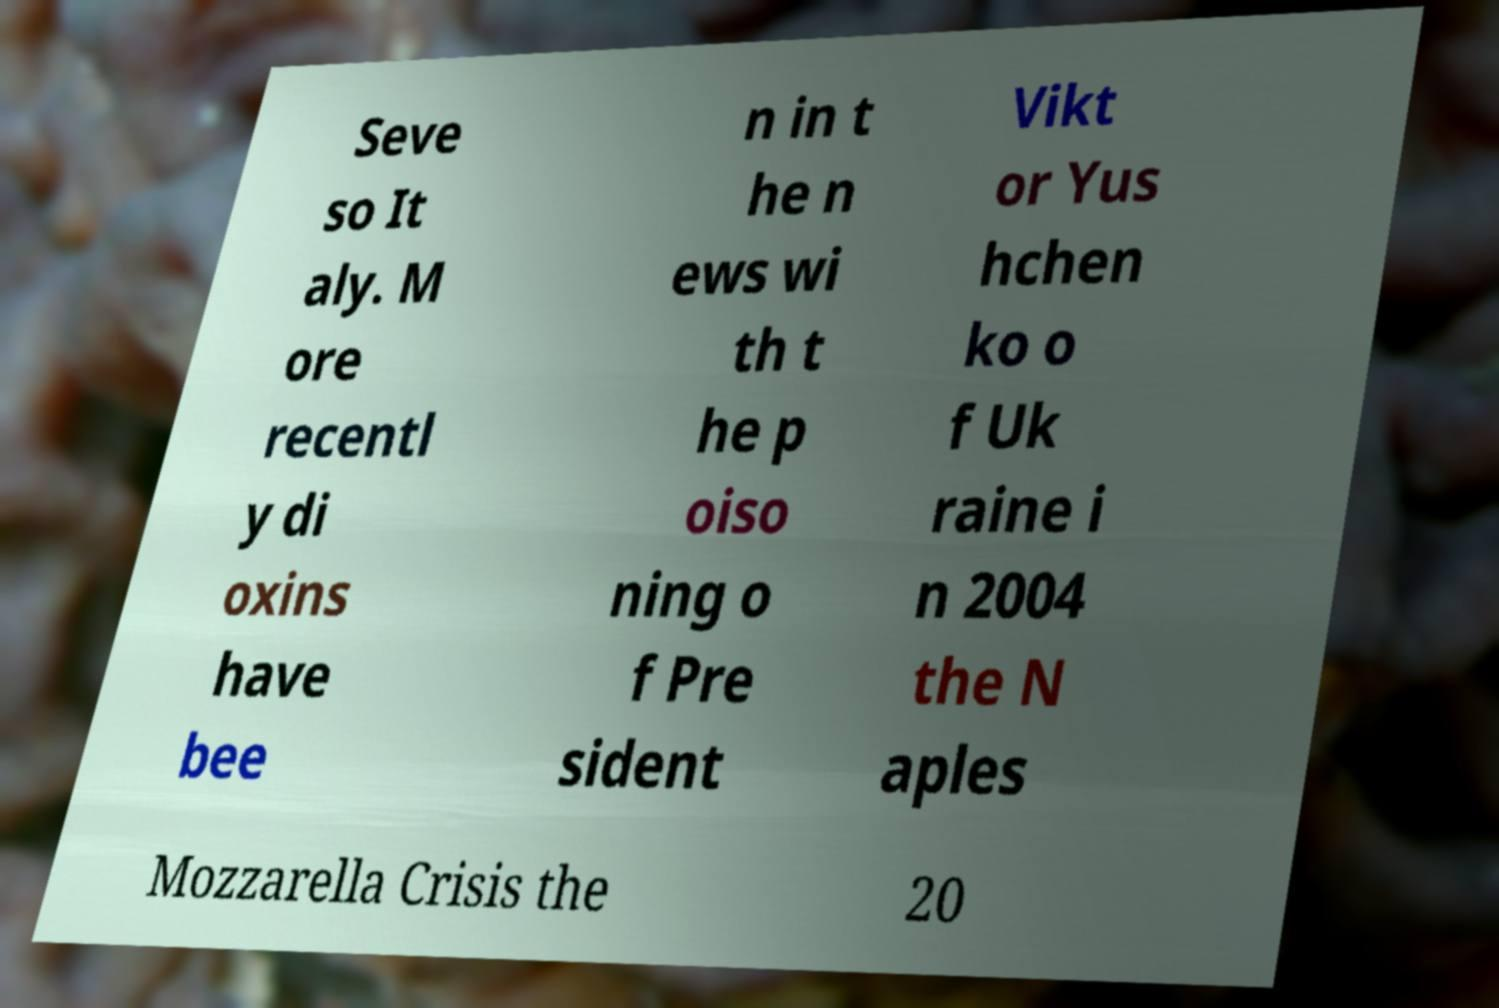What messages or text are displayed in this image? I need them in a readable, typed format. Seve so It aly. M ore recentl y di oxins have bee n in t he n ews wi th t he p oiso ning o f Pre sident Vikt or Yus hchen ko o f Uk raine i n 2004 the N aples Mozzarella Crisis the 20 